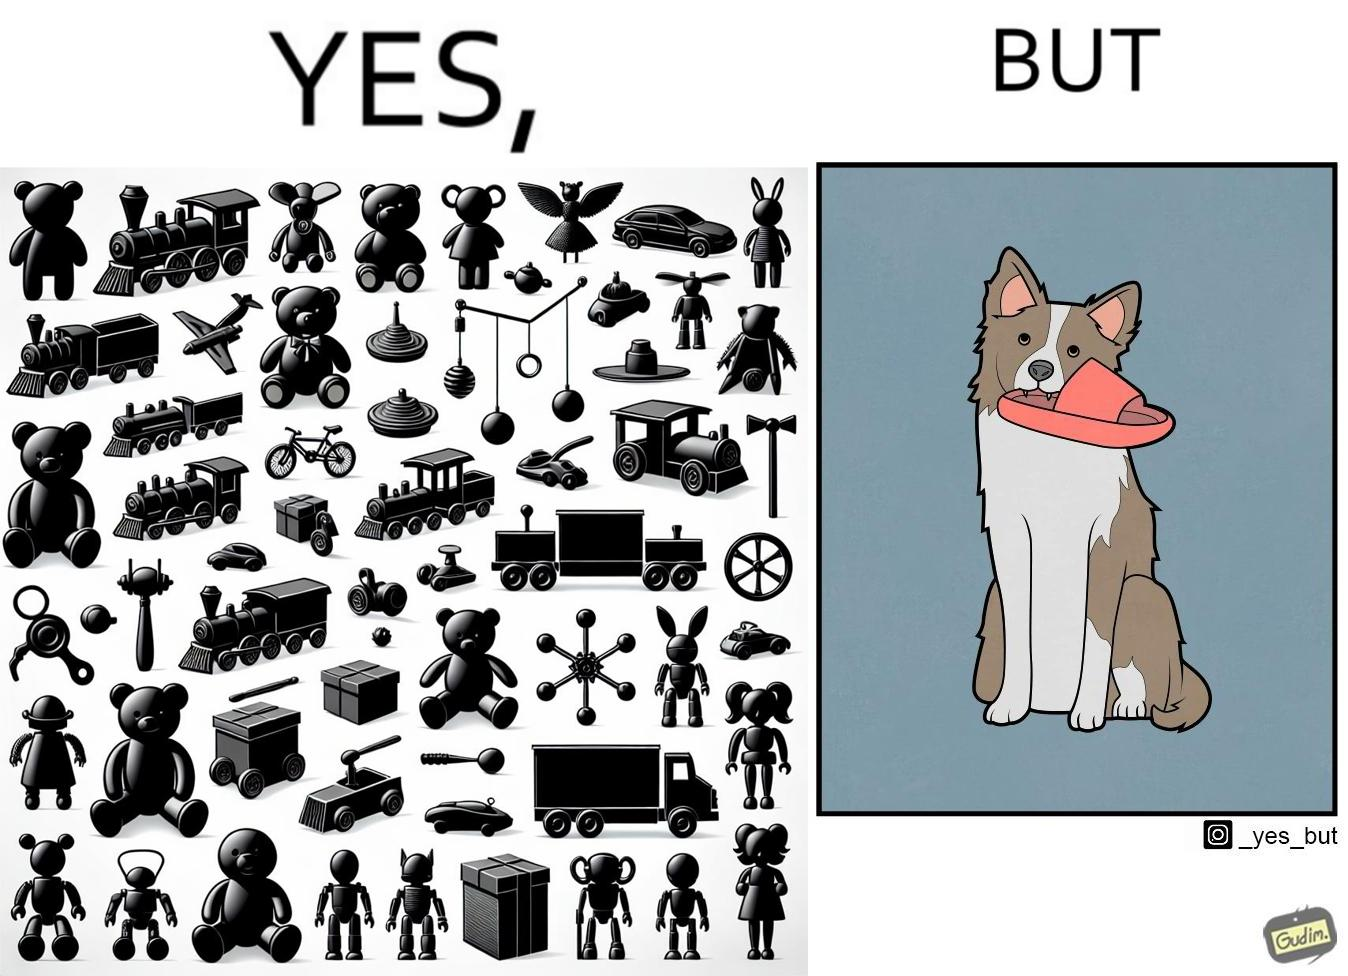Is this image satirical or non-satirical? Yes, this image is satirical. 